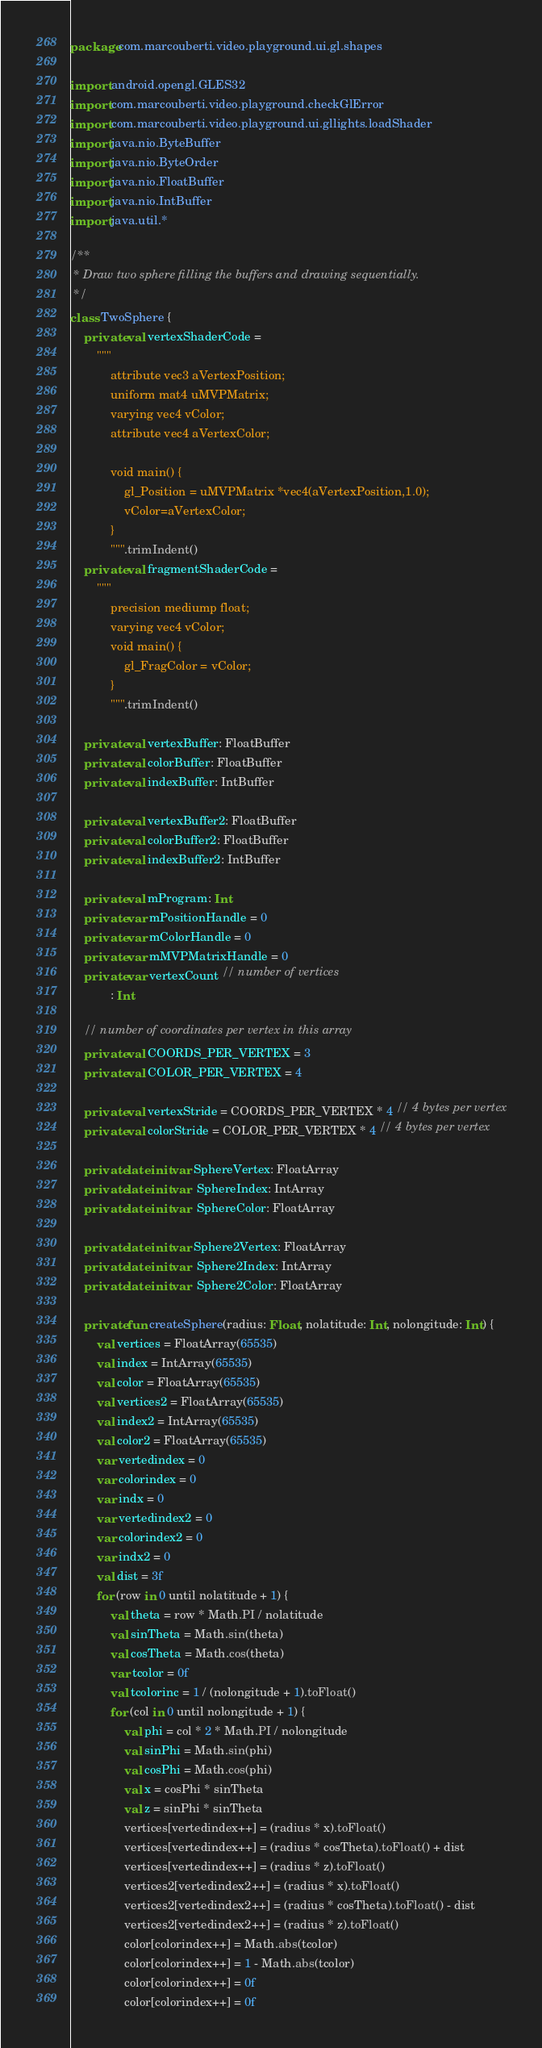<code> <loc_0><loc_0><loc_500><loc_500><_Kotlin_>package com.marcouberti.video.playground.ui.gl.shapes

import android.opengl.GLES32
import com.marcouberti.video.playground.checkGlError
import com.marcouberti.video.playground.ui.gllights.loadShader
import java.nio.ByteBuffer
import java.nio.ByteOrder
import java.nio.FloatBuffer
import java.nio.IntBuffer
import java.util.*

/**
 * Draw two sphere filling the buffers and drawing sequentially.
 */
class TwoSphere {
    private val vertexShaderCode =
        """
            attribute vec3 aVertexPosition;
            uniform mat4 uMVPMatrix;
            varying vec4 vColor;
            attribute vec4 aVertexColor;
            
            void main() {
                gl_Position = uMVPMatrix *vec4(aVertexPosition,1.0);
                vColor=aVertexColor;
            }
            """.trimIndent()
    private val fragmentShaderCode =
        """
            precision mediump float;
            varying vec4 vColor; 
            void main() {
                gl_FragColor = vColor;
            }
            """.trimIndent()
    
    private val vertexBuffer: FloatBuffer
    private val colorBuffer: FloatBuffer
    private val indexBuffer: IntBuffer

    private val vertexBuffer2: FloatBuffer
    private val colorBuffer2: FloatBuffer
    private val indexBuffer2: IntBuffer
    
    private val mProgram: Int
    private var mPositionHandle = 0
    private var mColorHandle = 0
    private var mMVPMatrixHandle = 0
    private var vertexCount // number of vertices
            : Int

    // number of coordinates per vertex in this array
    private val COORDS_PER_VERTEX = 3
    private val COLOR_PER_VERTEX = 4

    private val vertexStride = COORDS_PER_VERTEX * 4 // 4 bytes per vertex
    private val colorStride = COLOR_PER_VERTEX * 4 // 4 bytes per vertex

    private lateinit var SphereVertex: FloatArray
    private lateinit var  SphereIndex: IntArray
    private lateinit var  SphereColor: FloatArray

    private lateinit var Sphere2Vertex: FloatArray
    private lateinit var  Sphere2Index: IntArray
    private lateinit var  Sphere2Color: FloatArray

    private fun createSphere(radius: Float, nolatitude: Int, nolongitude: Int) {
        val vertices = FloatArray(65535)
        val index = IntArray(65535)
        val color = FloatArray(65535)
        val vertices2 = FloatArray(65535)
        val index2 = IntArray(65535)
        val color2 = FloatArray(65535)
        var vertedindex = 0
        var colorindex = 0
        var indx = 0
        var vertedindex2 = 0
        var colorindex2 = 0
        var indx2 = 0
        val dist = 3f
        for (row in 0 until nolatitude + 1) {
            val theta = row * Math.PI / nolatitude
            val sinTheta = Math.sin(theta)
            val cosTheta = Math.cos(theta)
            var tcolor = 0f
            val tcolorinc = 1 / (nolongitude + 1).toFloat()
            for (col in 0 until nolongitude + 1) {
                val phi = col * 2 * Math.PI / nolongitude
                val sinPhi = Math.sin(phi)
                val cosPhi = Math.cos(phi)
                val x = cosPhi * sinTheta
                val z = sinPhi * sinTheta
                vertices[vertedindex++] = (radius * x).toFloat()
                vertices[vertedindex++] = (radius * cosTheta).toFloat() + dist
                vertices[vertedindex++] = (radius * z).toFloat()
                vertices2[vertedindex2++] = (radius * x).toFloat()
                vertices2[vertedindex2++] = (radius * cosTheta).toFloat() - dist
                vertices2[vertedindex2++] = (radius * z).toFloat()
                color[colorindex++] = Math.abs(tcolor)
                color[colorindex++] = 1 - Math.abs(tcolor)
                color[colorindex++] = 0f
                color[colorindex++] = 0f</code> 